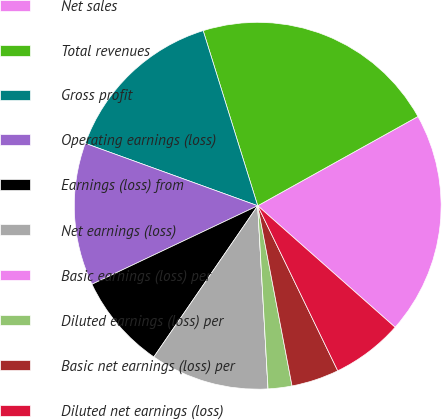Convert chart to OTSL. <chart><loc_0><loc_0><loc_500><loc_500><pie_chart><fcel>Net sales<fcel>Total revenues<fcel>Gross profit<fcel>Operating earnings (loss)<fcel>Earnings (loss) from<fcel>Net earnings (loss)<fcel>Basic earnings (loss) per<fcel>Diluted earnings (loss) per<fcel>Basic net earnings (loss) per<fcel>Diluted net earnings (loss)<nl><fcel>19.62%<fcel>21.72%<fcel>14.67%<fcel>12.57%<fcel>8.38%<fcel>10.48%<fcel>0.0%<fcel>2.1%<fcel>4.19%<fcel>6.29%<nl></chart> 